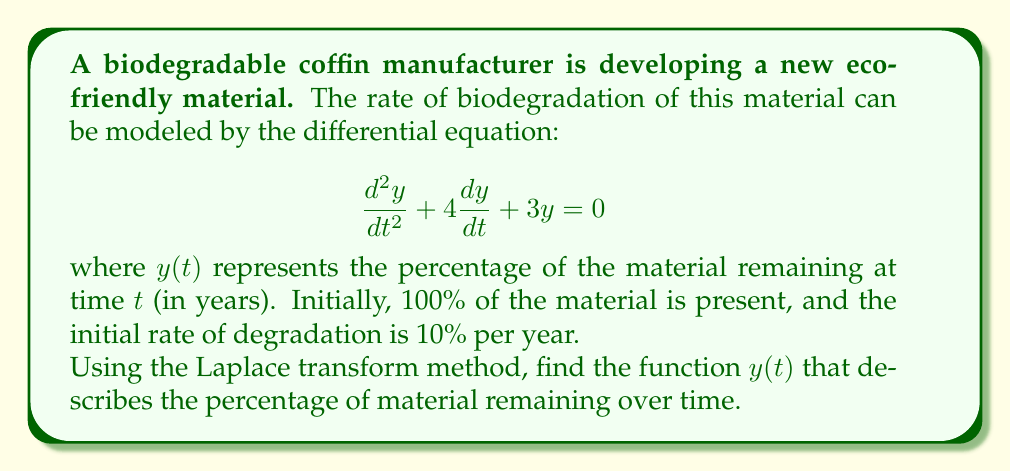Could you help me with this problem? Let's solve this step-by-step using the Laplace transform method:

1) First, let's define our initial conditions:
   $y(0) = 100$ (100% material at $t=0$)
   $y'(0) = -10$ (initial degradation rate of 10% per year)

2) Take the Laplace transform of both sides of the differential equation:
   $$\mathcal{L}\{y''(t) + 4y'(t) + 3y(t)\} = \mathcal{L}\{0\}$$

3) Using Laplace transform properties:
   $$[s^2Y(s) - sy(0) - y'(0)] + 4[sY(s) - y(0)] + 3Y(s) = 0$$

4) Substitute the initial conditions:
   $$[s^2Y(s) - 100s + 10] + 4[sY(s) - 100] + 3Y(s) = 0$$

5) Simplify:
   $$s^2Y(s) - 100s + 10 + 4sY(s) - 400 + 3Y(s) = 0$$
   $$(s^2 + 4s + 3)Y(s) = 100s + 390$$

6) Solve for Y(s):
   $$Y(s) = \frac{100s + 390}{s^2 + 4s + 3}$$

7) Factor the denominator:
   $$Y(s) = \frac{100s + 390}{(s+1)(s+3)}$$

8) Use partial fraction decomposition:
   $$Y(s) = \frac{A}{s+1} + \frac{B}{s+3}$$

   where $A$ and $B$ are constants to be determined.

9) Solve for A and B:
   $100s + 390 = A(s+3) + B(s+1)$
   Comparing coefficients:
   $s: 100 = A + B$
   constant: $390 = 3A + B$
   Solving these equations: $A = 95$, $B = 5$

10) Therefore:
    $$Y(s) = \frac{95}{s+1} + \frac{5}{s+3}$$

11) Take the inverse Laplace transform:
    $$y(t) = 95e^{-t} + 5e^{-3t}$$

This is the solution that describes the percentage of material remaining over time.
Answer: $y(t) = 95e^{-t} + 5e^{-3t}$ 